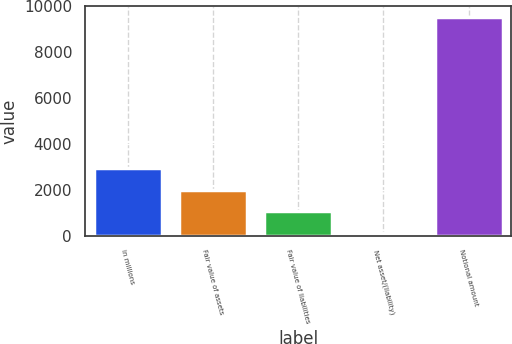Convert chart to OTSL. <chart><loc_0><loc_0><loc_500><loc_500><bar_chart><fcel>in millions<fcel>Fair value of assets<fcel>Fair value of liabilities<fcel>Net asset/(liability)<fcel>Notional amount<nl><fcel>2941.6<fcel>2000.4<fcel>1059.2<fcel>118<fcel>9530<nl></chart> 